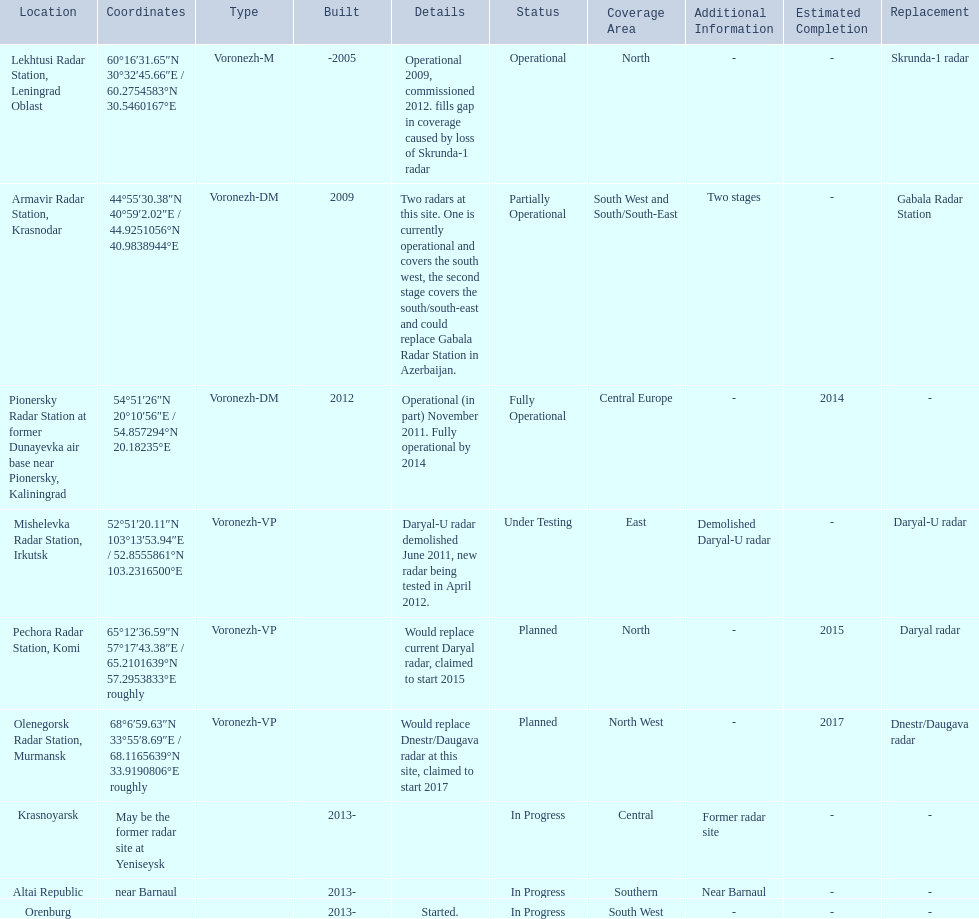Where is each radar? Lekhtusi Radar Station, Leningrad Oblast, Armavir Radar Station, Krasnodar, Pionersky Radar Station at former Dunayevka air base near Pionersky, Kaliningrad, Mishelevka Radar Station, Irkutsk, Pechora Radar Station, Komi, Olenegorsk Radar Station, Murmansk, Krasnoyarsk, Altai Republic, Orenburg. What are the details of each radar? Operational 2009, commissioned 2012. fills gap in coverage caused by loss of Skrunda-1 radar, Two radars at this site. One is currently operational and covers the south west, the second stage covers the south/south-east and could replace Gabala Radar Station in Azerbaijan., Operational (in part) November 2011. Fully operational by 2014, Daryal-U radar demolished June 2011, new radar being tested in April 2012., Would replace current Daryal radar, claimed to start 2015, Would replace Dnestr/Daugava radar at this site, claimed to start 2017, , , Started. Which radar is detailed to start in 2015? Pechora Radar Station, Komi. 